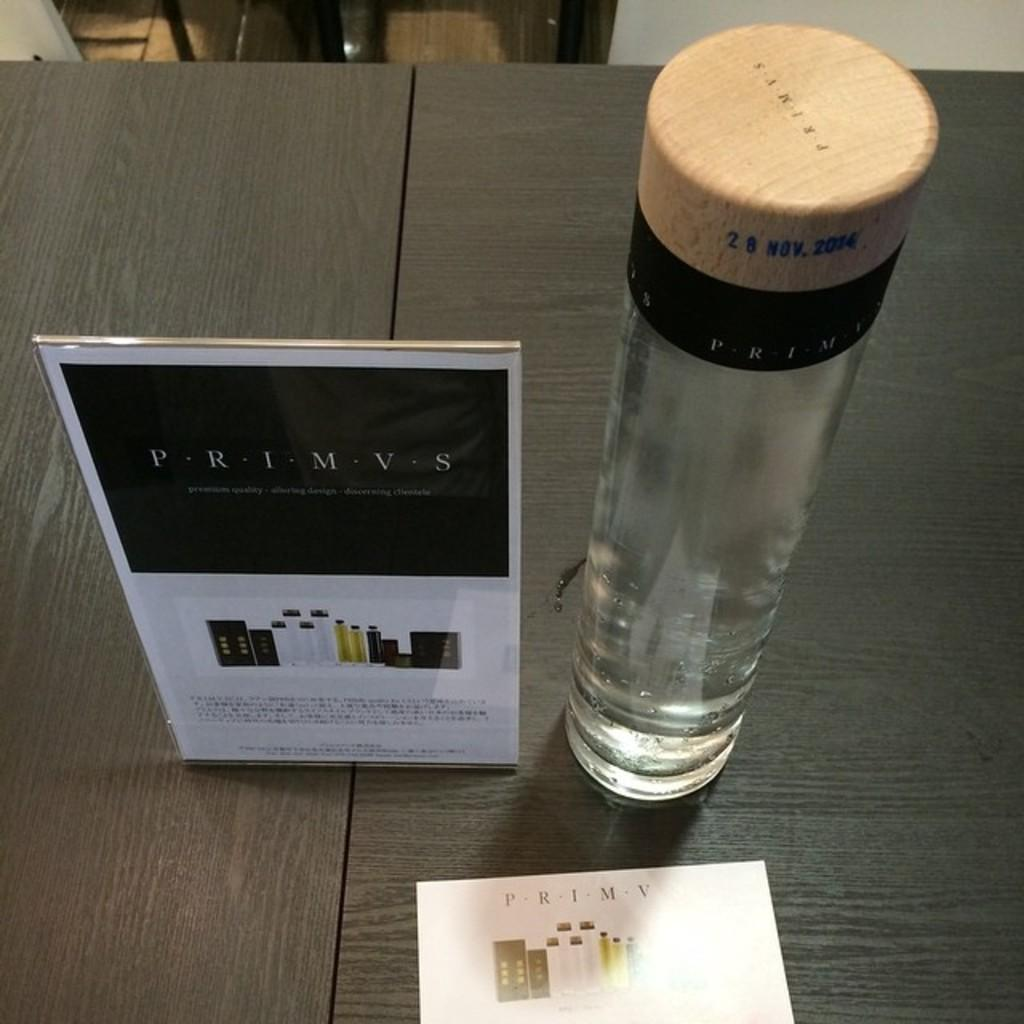<image>
Provide a brief description of the given image. A display set up on a table a brand name PRIMVS with a glass bottle and information signs. 